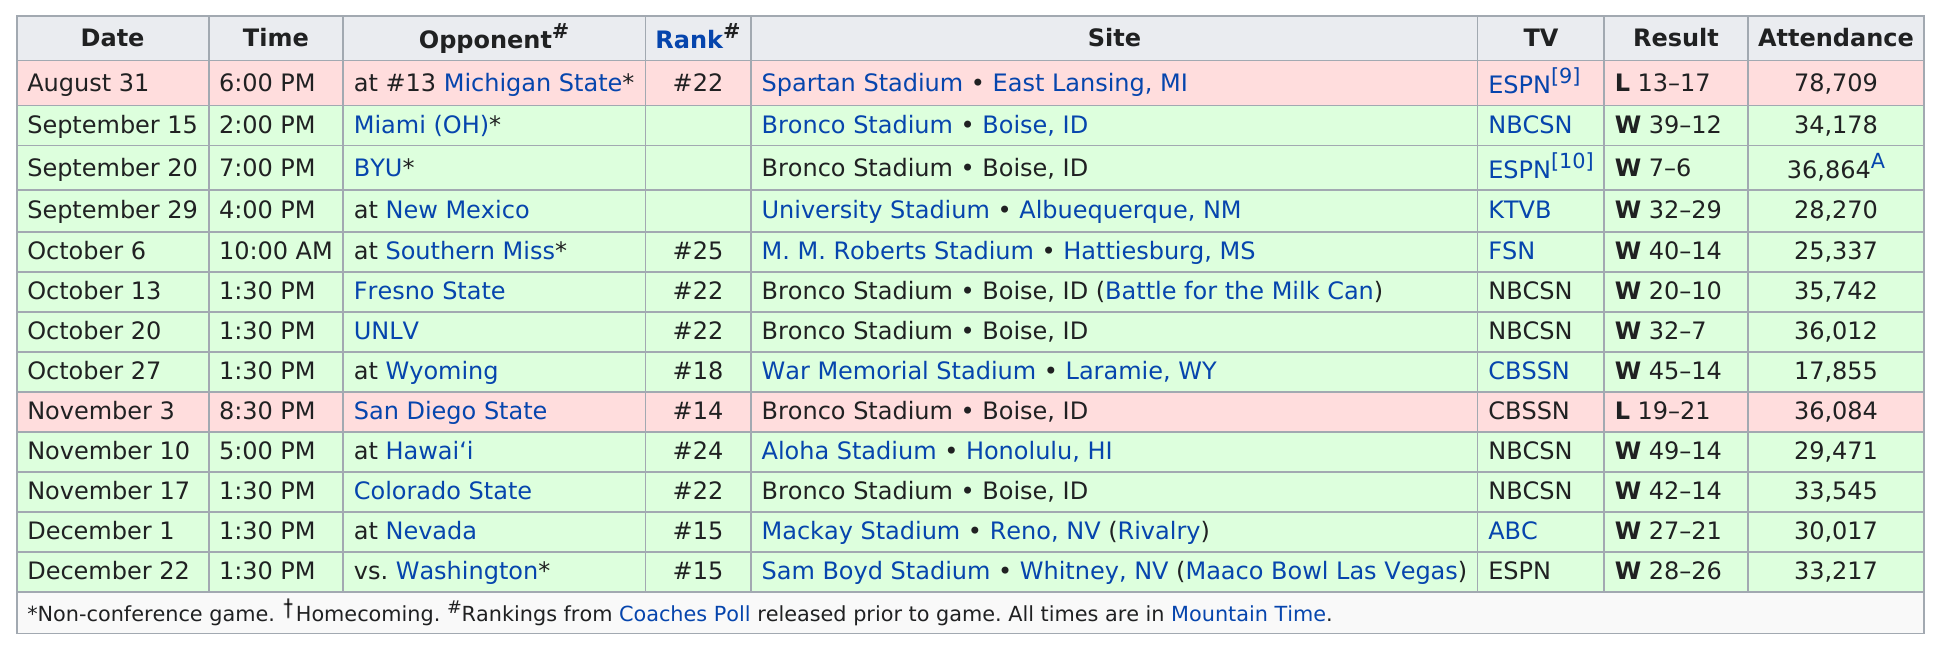Mention a couple of crucial points in this snapshot. After facing the University of Nevada, Las Vegas, the opponent that the Denver Broncos will face next is the University of Wyoming. The team achieved a remarkable streak of seven consecutive wins during the season. The score difference for the game against Michigan State is 4. The last game of the season was against the opponent of Washington, which was the final match of the season. In the matchup between Miami (OH) and the Broncos, Miami (OH) scored 12 points. 